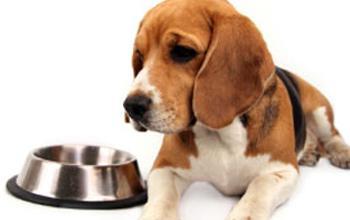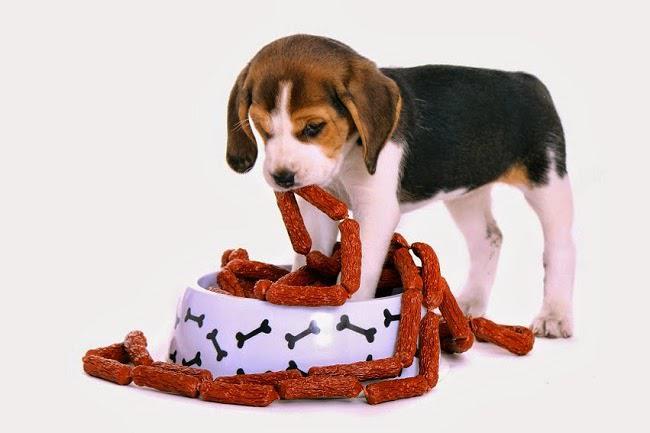The first image is the image on the left, the second image is the image on the right. Considering the images on both sides, is "A beagle is eating sausages." valid? Answer yes or no. Yes. 